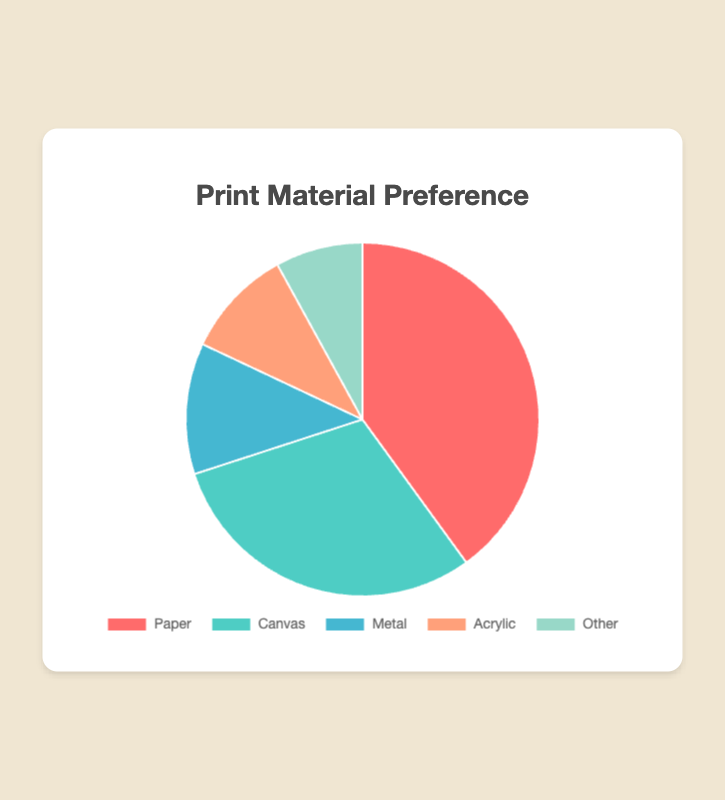What percentage of customers prefer prints on Canvas over Paper? The percentage of customers preferring prints on Canvas is 30%, while those preferring Paper is 40%. The difference is calculated as 40% - 30% = 10%.
Answer: 30% What is the most popular print material among customers? The most popular print material is the one with the highest percentage. Here, Paper has the highest percentage at 40%.
Answer: Paper How much more popular is Metal compared to Acrylic? Metal is preferred by 12% of customers, whereas Acrylic is preferred by 10%. The difference is calculated as 12% - 10% = 2%.
Answer: 2% What is the sum of the percentages for Canvas and Acrylic? The percentage for Canvas is 30% and for Acrylic is 10%. The sum is 30% + 10% = 40%.
Answer: 40% Which print material is the least preferred by customers? The least preferred print material is the one with the lowest percentage. Here, "Other" has the lowest percentage at 8%.
Answer: Other How do the preferences for Metal and Other compare to the preference for Paper? The preference for Metal is 12%, and for Other is 8%. Combined, they make 12% + 8% = 20%. Paper preference is 40%, so Paper is preferred 20% more than Metal and Other combined.
Answer: 20% What is the combined percentage of customers preferring Metal, Acrylic, and Other? The percentage for Metal is 12%, for Acrylic is 10%, and for Other is 8%. The combined percentage is 12% + 10% + 8% = 30%.
Answer: 30% Is the sum of the percentages of Acrylic and Other greater than that of Metal? The percentages for Acrylic and Other are 10% and 8%, respectively. Their sum is 10% + 8% = 18%. Since Metal is 12%, 18% is greater than 12%.
Answer: Yes What is the total percentage of customers preferring non-paper materials? The percentages for non-paper materials are Canvas (30%), Metal (12%), Acrylic (10%), and Other (8%). The total is 30% + 12% + 10% + 8% = 60%.
Answer: 60% Which print material is represented by the second largest area? By percentage, the second largest area is represented by Canvas at 30%.
Answer: Canvas 